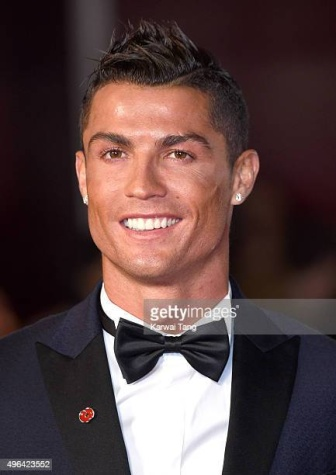What does the red flower on Ronaldo's lapel signify? The red flower pinned on Cristiano Ronaldo's lapel is likely a symbol of solidarity or support for a cause, which is a common practice at celebrity events to raise awareness. Depending upon the specific occasion, such as a charity event or awareness campaign, the red flower could represent his commitment to contributing positively to the community. 